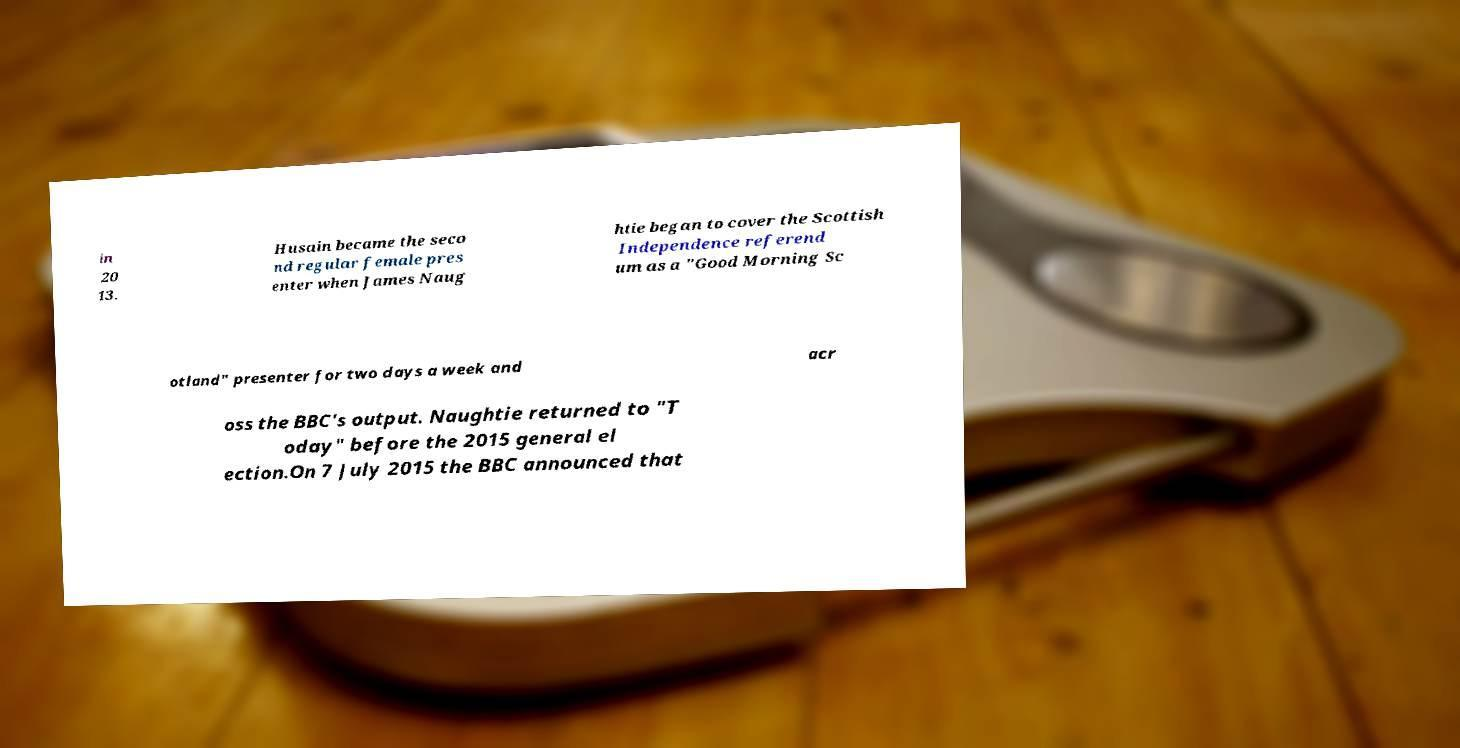Can you accurately transcribe the text from the provided image for me? in 20 13. Husain became the seco nd regular female pres enter when James Naug htie began to cover the Scottish Independence referend um as a "Good Morning Sc otland" presenter for two days a week and acr oss the BBC's output. Naughtie returned to "T oday" before the 2015 general el ection.On 7 July 2015 the BBC announced that 